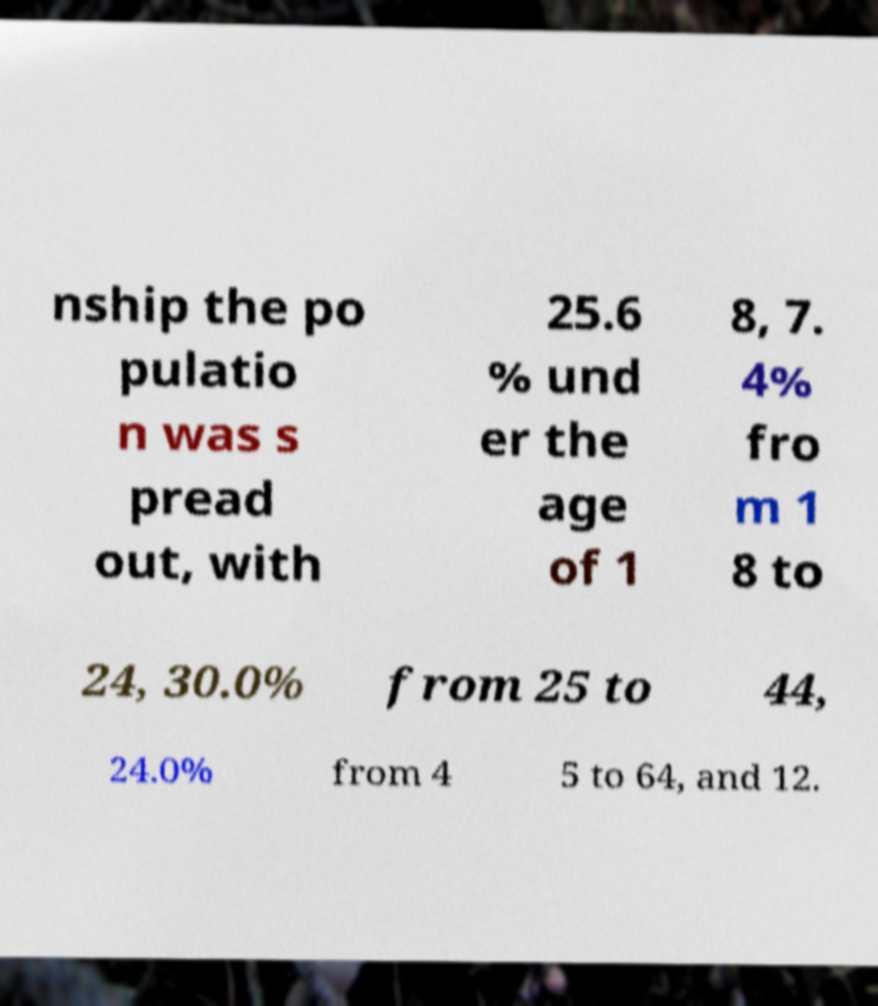Could you assist in decoding the text presented in this image and type it out clearly? nship the po pulatio n was s pread out, with 25.6 % und er the age of 1 8, 7. 4% fro m 1 8 to 24, 30.0% from 25 to 44, 24.0% from 4 5 to 64, and 12. 